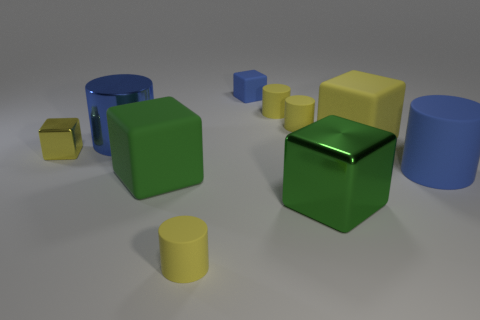Do the green rubber thing and the big blue metal thing have the same shape?
Keep it short and to the point. No. Are there the same number of big blue things behind the small yellow shiny block and tiny yellow matte cylinders on the right side of the big blue metallic cylinder?
Ensure brevity in your answer.  No. What number of other objects are there of the same material as the large yellow object?
Your answer should be compact. 6. How many small things are either green cubes or brown matte blocks?
Offer a very short reply. 0. Is the number of tiny blue rubber objects in front of the big green rubber thing the same as the number of big blue metallic things?
Give a very brief answer. No. There is a small yellow thing in front of the small yellow shiny object; are there any blue metal cylinders in front of it?
Provide a short and direct response. No. How many other objects are there of the same color as the small metallic block?
Ensure brevity in your answer.  4. What is the color of the large shiny cylinder?
Give a very brief answer. Blue. There is a block that is in front of the yellow matte block and right of the green matte block; how big is it?
Keep it short and to the point. Large. What number of things are tiny cylinders that are in front of the yellow metallic cube or big cylinders?
Ensure brevity in your answer.  3. 